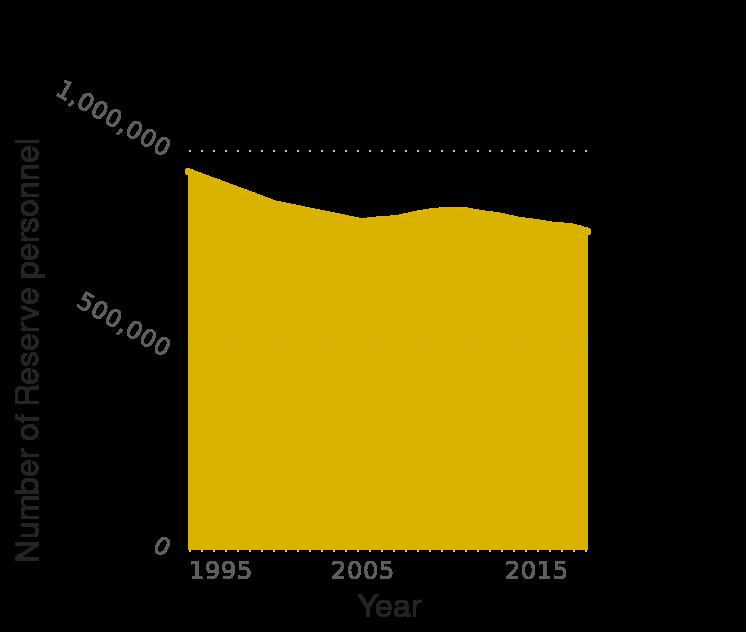<image>
What is the highest value represented on the y-axis in the graph? The highest value represented on the y-axis in the graph is 1,000,000. 